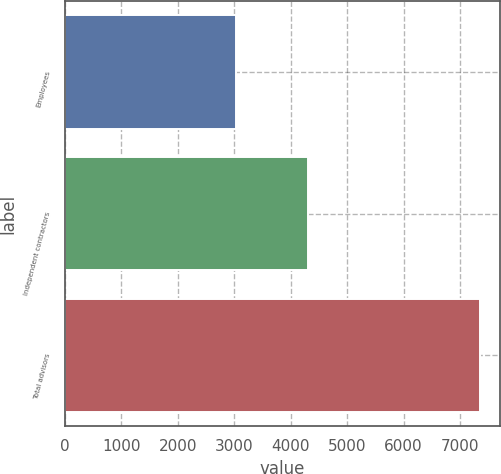<chart> <loc_0><loc_0><loc_500><loc_500><bar_chart><fcel>Employees<fcel>Independent contractors<fcel>Total advisors<nl><fcel>3041<fcel>4305<fcel>7346<nl></chart> 